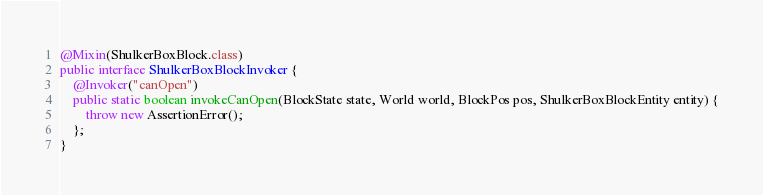Convert code to text. <code><loc_0><loc_0><loc_500><loc_500><_Java_>
@Mixin(ShulkerBoxBlock.class)
public interface ShulkerBoxBlockInvoker {
	@Invoker("canOpen")
	public static boolean invokeCanOpen(BlockState state, World world, BlockPos pos, ShulkerBoxBlockEntity entity) {
		throw new AssertionError();
	};
}
</code> 